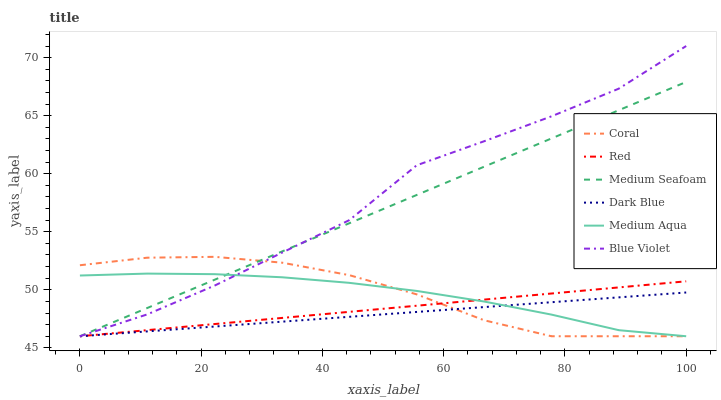Does Dark Blue have the minimum area under the curve?
Answer yes or no. Yes. Does Blue Violet have the maximum area under the curve?
Answer yes or no. Yes. Does Medium Aqua have the minimum area under the curve?
Answer yes or no. No. Does Medium Aqua have the maximum area under the curve?
Answer yes or no. No. Is Dark Blue the smoothest?
Answer yes or no. Yes. Is Blue Violet the roughest?
Answer yes or no. Yes. Is Medium Aqua the smoothest?
Answer yes or no. No. Is Medium Aqua the roughest?
Answer yes or no. No. Does Coral have the lowest value?
Answer yes or no. Yes. Does Blue Violet have the highest value?
Answer yes or no. Yes. Does Medium Aqua have the highest value?
Answer yes or no. No. Does Medium Aqua intersect Medium Seafoam?
Answer yes or no. Yes. Is Medium Aqua less than Medium Seafoam?
Answer yes or no. No. Is Medium Aqua greater than Medium Seafoam?
Answer yes or no. No. 